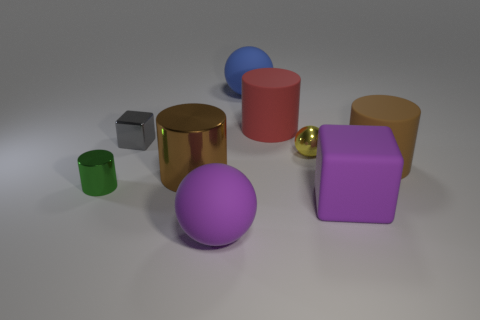What number of tiny gray shiny objects have the same shape as the big metallic thing? There is one small gray shiny cube that has the same shape as the larger metallic cube in the image. 